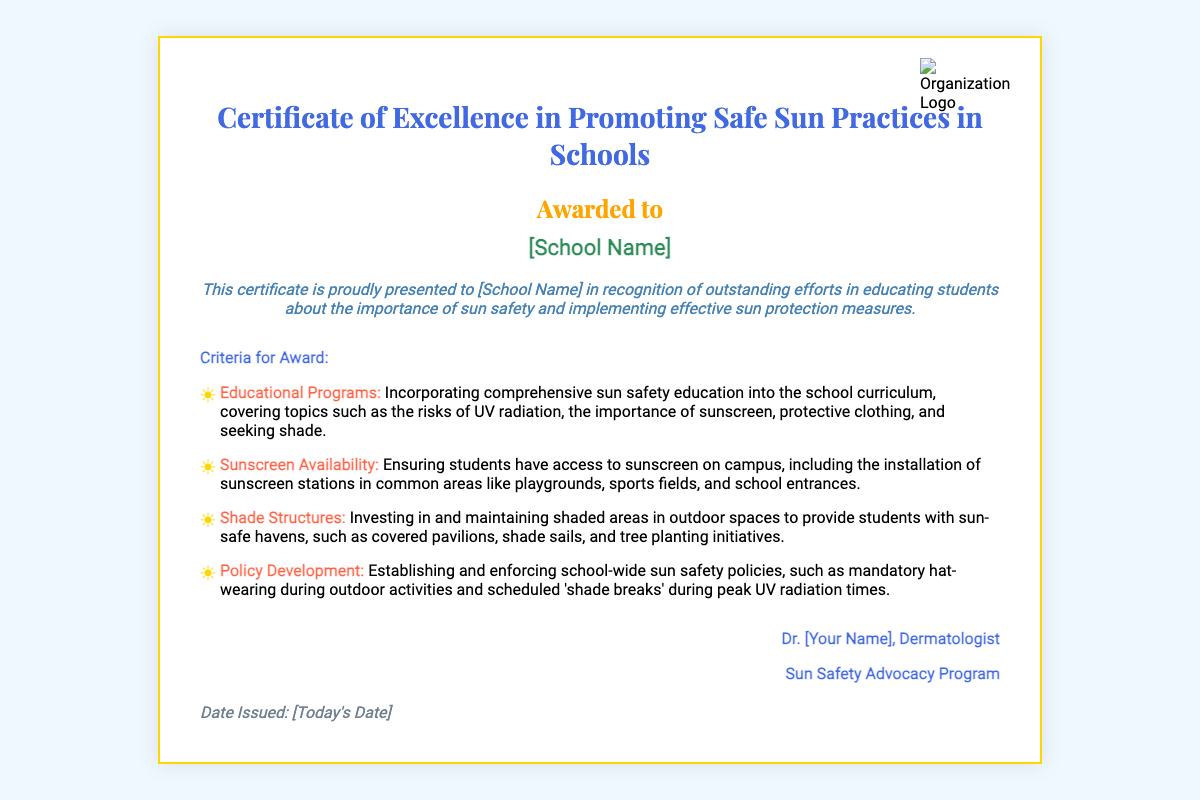What is the title of the certificate? The title of the certificate is prominently displayed at the top of the document.
Answer: Certificate of Excellence in Promoting Safe Sun Practices in Schools Who is the certificate awarded to? The recipient's name is specifically mentioned in a designated area of the document.
Answer: [School Name] What is the focus of the educational programs mentioned? The educational programs should cover specific topics related to sun safety, which are indicated in the document.
Answer: Risks of UV radiation What is one of the criteria for award related to sunscreen? The document specifies a criteria related to sunscreen availability that is focused on a specific action.
Answer: Sunscreen availability Who signed the certificate? The signature section includes the name and title of the person endorsing the certificate.
Answer: Dr. [Your Name] What type of safety measures does the certificate promote? The document outlines general safety measures that are aimed at sun protection for students.
Answer: Sun protection measures How many criteria for the award are listed? The number of criteria mentioned can be counted in the list provided in the document.
Answer: Four What kind of outdoor structures are mentioned for providing shade? The document mentions specific structures related to shade during outdoor activities.
Answer: Shade structures 